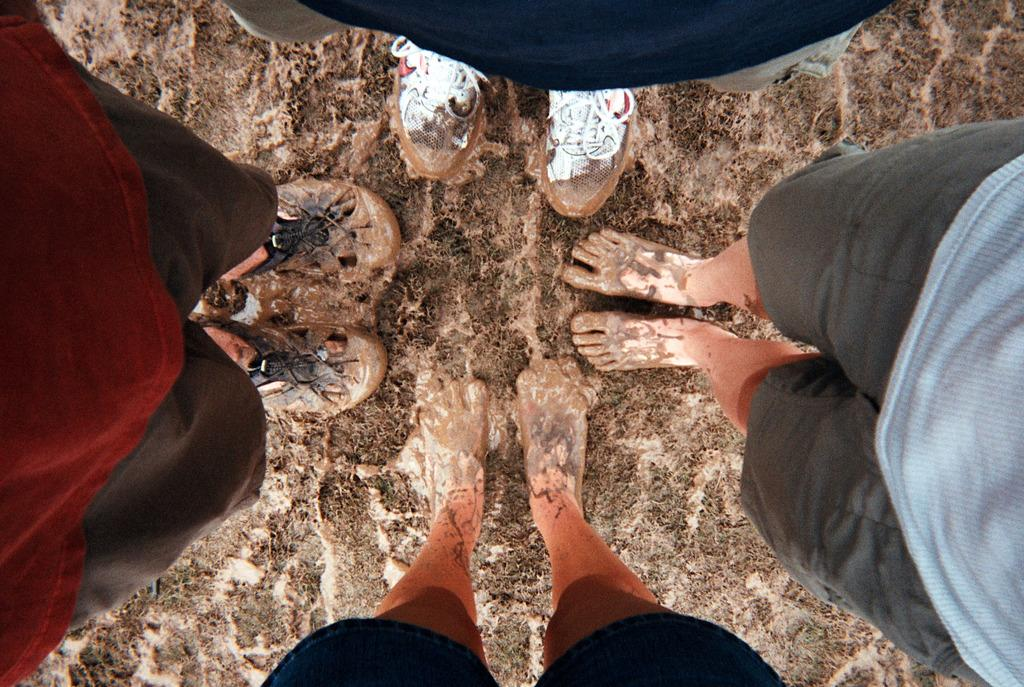How many people are in the image? There are four people in the image. What is the surface they are standing on? The people are standing on a wet mud floor. Can you describe the condition of their feet? Mud is present around their feet. What type of music can be heard playing in the background of the image? There is no indication of music or any sound in the image, so it cannot be determined from the picture. 